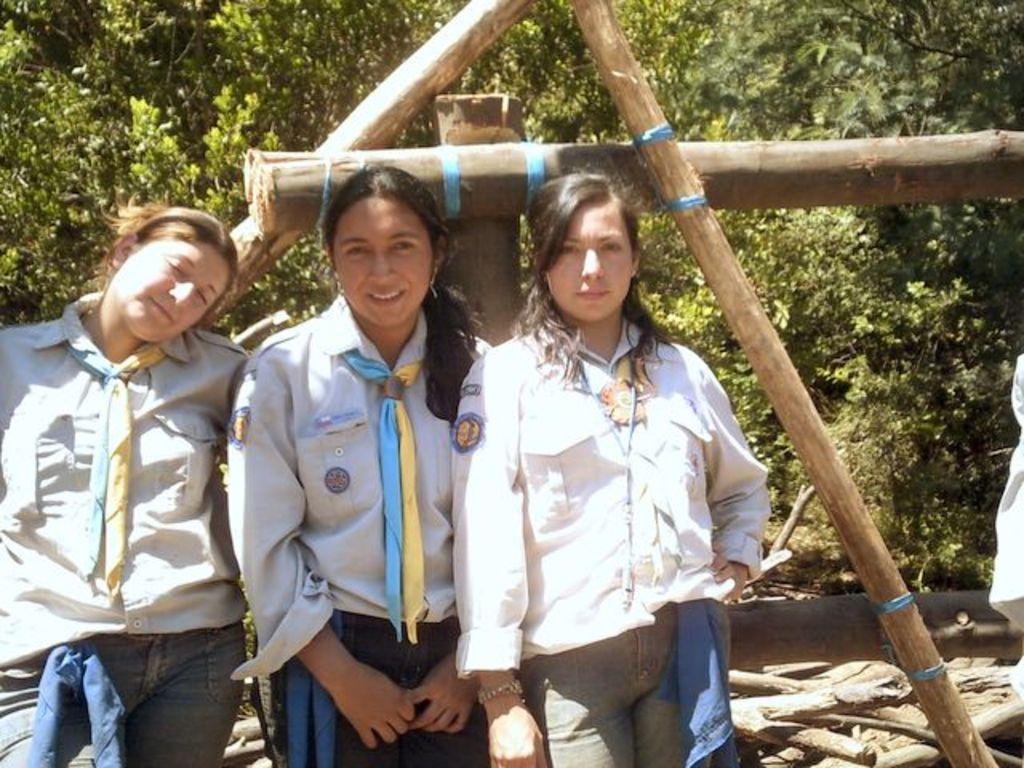How would you summarize this image in a sentence or two? In the center of the image we can see three ladies standing. In the background there are trees, logs and grass. 